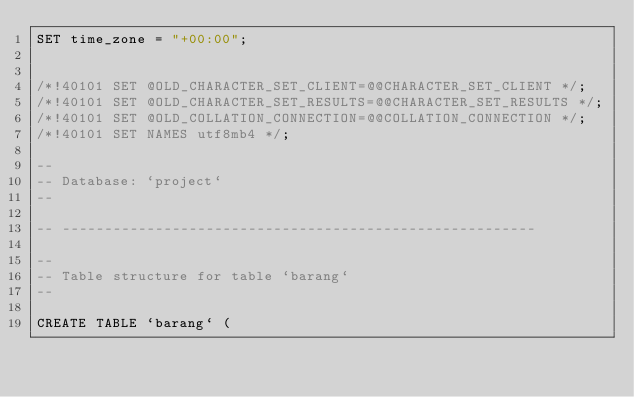<code> <loc_0><loc_0><loc_500><loc_500><_SQL_>SET time_zone = "+00:00";


/*!40101 SET @OLD_CHARACTER_SET_CLIENT=@@CHARACTER_SET_CLIENT */;
/*!40101 SET @OLD_CHARACTER_SET_RESULTS=@@CHARACTER_SET_RESULTS */;
/*!40101 SET @OLD_COLLATION_CONNECTION=@@COLLATION_CONNECTION */;
/*!40101 SET NAMES utf8mb4 */;

--
-- Database: `project`
--

-- --------------------------------------------------------

--
-- Table structure for table `barang`
--

CREATE TABLE `barang` (</code> 